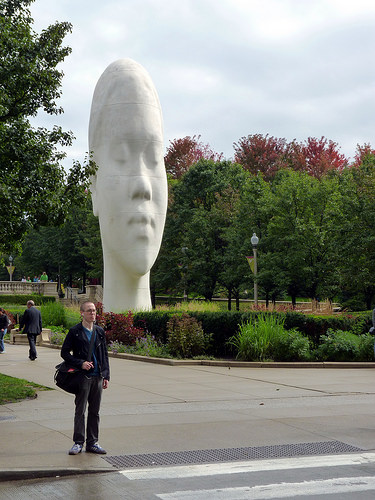<image>
Can you confirm if the head is on the man? No. The head is not positioned on the man. They may be near each other, but the head is not supported by or resting on top of the man. Is the neck in the bush? Yes. The neck is contained within or inside the bush, showing a containment relationship. 